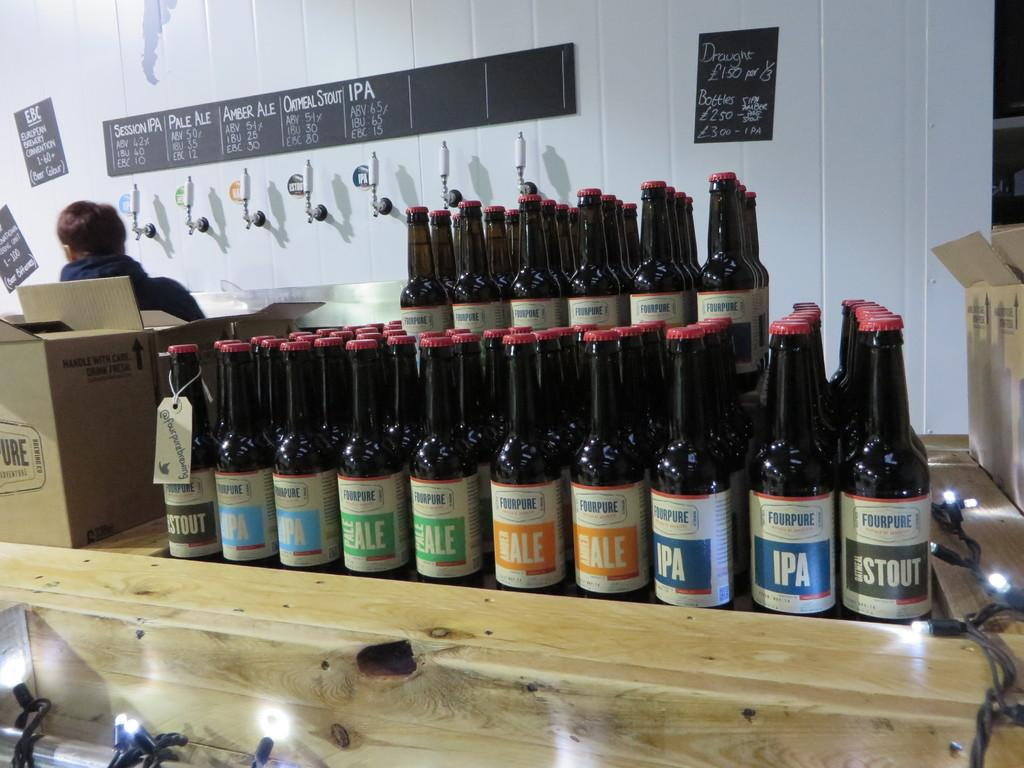<image>
Write a terse but informative summary of the picture. A display of beer bottles feature labels of various colors and classifications like IPA, ale, and stout. 